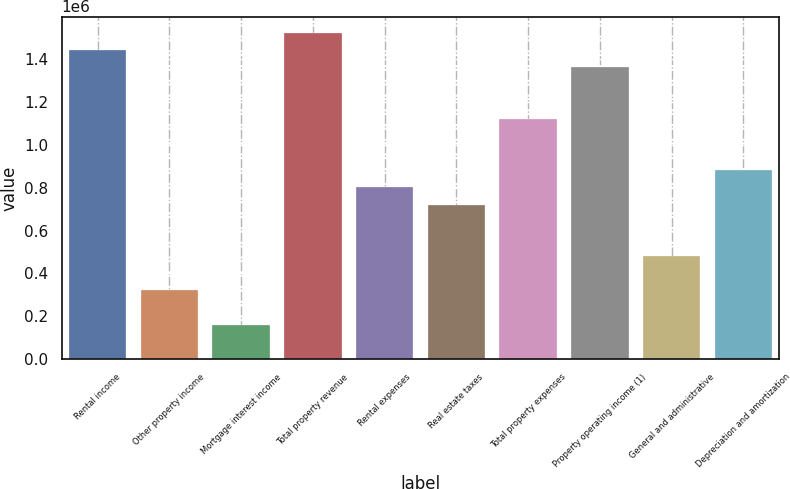Convert chart. <chart><loc_0><loc_0><loc_500><loc_500><bar_chart><fcel>Rental income<fcel>Other property income<fcel>Mortgage interest income<fcel>Total property revenue<fcel>Rental expenses<fcel>Real estate taxes<fcel>Total property expenses<fcel>Property operating income (1)<fcel>General and administrative<fcel>Depreciation and amortization<nl><fcel>1.44282e+06<fcel>320666<fcel>160358<fcel>1.52298e+06<fcel>801591<fcel>721437<fcel>1.12221e+06<fcel>1.36267e+06<fcel>480975<fcel>881745<nl></chart> 